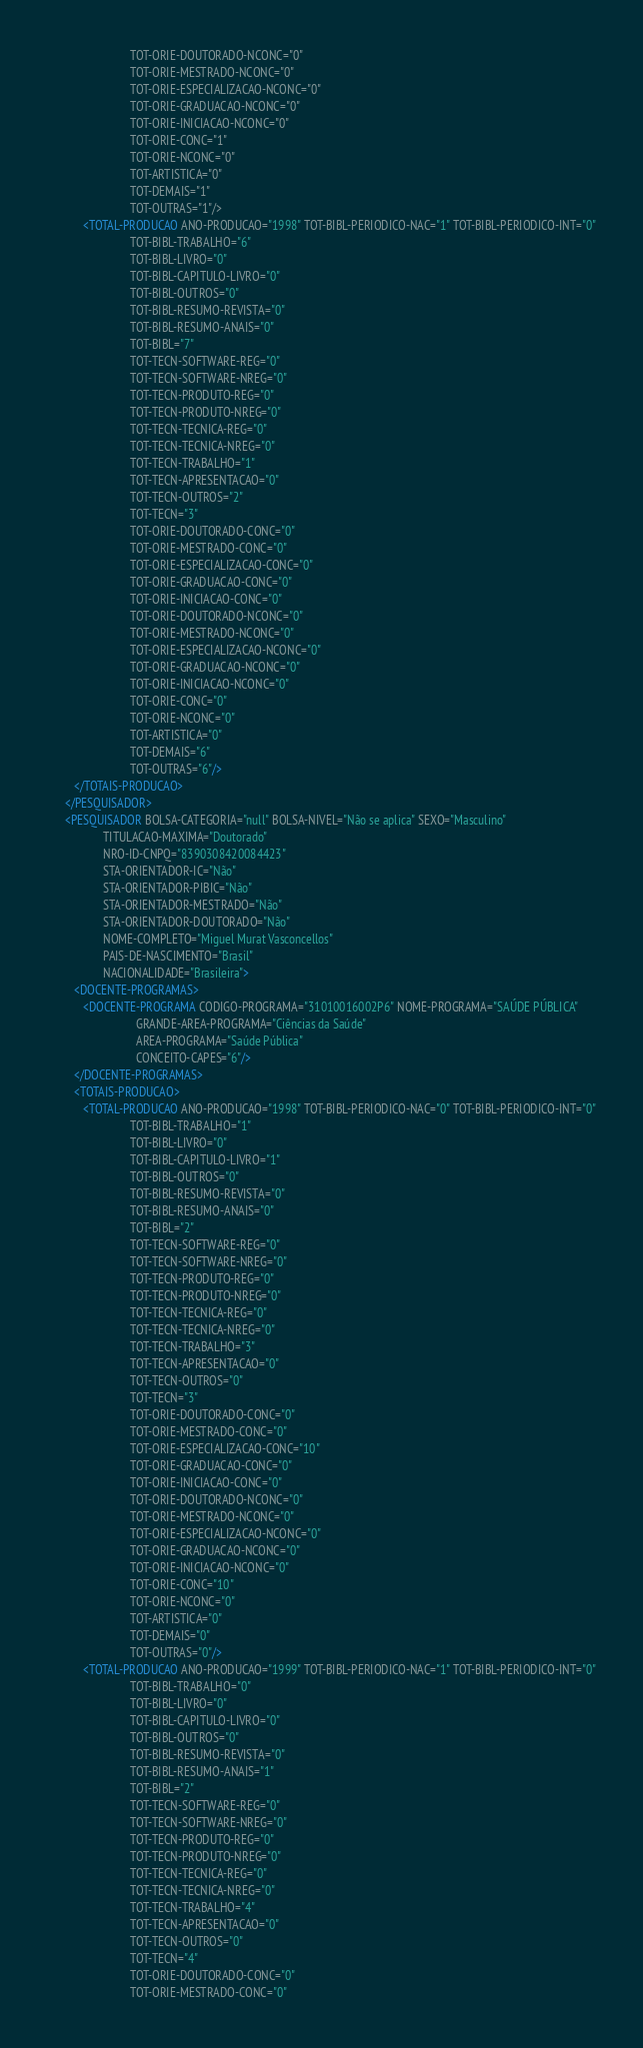<code> <loc_0><loc_0><loc_500><loc_500><_XML_>                            TOT-ORIE-DOUTORADO-NCONC="0"
                            TOT-ORIE-MESTRADO-NCONC="0"
                            TOT-ORIE-ESPECIALIZACAO-NCONC="0"
                            TOT-ORIE-GRADUACAO-NCONC="0"
                            TOT-ORIE-INICIACAO-NCONC="0"
                            TOT-ORIE-CONC="1"
                            TOT-ORIE-NCONC="0"
                            TOT-ARTISTICA="0"
                            TOT-DEMAIS="1"
                            TOT-OUTRAS="1"/>
            <TOTAL-PRODUCAO ANO-PRODUCAO="1998" TOT-BIBL-PERIODICO-NAC="1" TOT-BIBL-PERIODICO-INT="0"
                            TOT-BIBL-TRABALHO="6"
                            TOT-BIBL-LIVRO="0"
                            TOT-BIBL-CAPITULO-LIVRO="0"
                            TOT-BIBL-OUTROS="0"
                            TOT-BIBL-RESUMO-REVISTA="0"
                            TOT-BIBL-RESUMO-ANAIS="0"
                            TOT-BIBL="7"
                            TOT-TECN-SOFTWARE-REG="0"
                            TOT-TECN-SOFTWARE-NREG="0"
                            TOT-TECN-PRODUTO-REG="0"
                            TOT-TECN-PRODUTO-NREG="0"
                            TOT-TECN-TECNICA-REG="0"
                            TOT-TECN-TECNICA-NREG="0"
                            TOT-TECN-TRABALHO="1"
                            TOT-TECN-APRESENTACAO="0"
                            TOT-TECN-OUTROS="2"
                            TOT-TECN="3"
                            TOT-ORIE-DOUTORADO-CONC="0"
                            TOT-ORIE-MESTRADO-CONC="0"
                            TOT-ORIE-ESPECIALIZACAO-CONC="0"
                            TOT-ORIE-GRADUACAO-CONC="0"
                            TOT-ORIE-INICIACAO-CONC="0"
                            TOT-ORIE-DOUTORADO-NCONC="0"
                            TOT-ORIE-MESTRADO-NCONC="0"
                            TOT-ORIE-ESPECIALIZACAO-NCONC="0"
                            TOT-ORIE-GRADUACAO-NCONC="0"
                            TOT-ORIE-INICIACAO-NCONC="0"
                            TOT-ORIE-CONC="0"
                            TOT-ORIE-NCONC="0"
                            TOT-ARTISTICA="0"
                            TOT-DEMAIS="6"
                            TOT-OUTRAS="6"/>
         </TOTAIS-PRODUCAO>
      </PESQUISADOR>
      <PESQUISADOR BOLSA-CATEGORIA="null" BOLSA-NIVEL="Não se aplica" SEXO="Masculino"
                   TITULACAO-MAXIMA="Doutorado"
                   NRO-ID-CNPQ="8390308420084423"
                   STA-ORIENTADOR-IC="Não"
                   STA-ORIENTADOR-PIBIC="Não"
                   STA-ORIENTADOR-MESTRADO="Não"
                   STA-ORIENTADOR-DOUTORADO="Não"
                   NOME-COMPLETO="Miguel Murat Vasconcellos"
                   PAIS-DE-NASCIMENTO="Brasil"
                   NACIONALIDADE="Brasileira">
         <DOCENTE-PROGRAMAS>
            <DOCENTE-PROGRAMA CODIGO-PROGRAMA="31010016002P6" NOME-PROGRAMA="SAÚDE PÚBLICA"
                              GRANDE-AREA-PROGRAMA="Ciências da Saúde"
                              AREA-PROGRAMA="Saúde Pública"
                              CONCEITO-CAPES="6"/>
         </DOCENTE-PROGRAMAS>
         <TOTAIS-PRODUCAO>
            <TOTAL-PRODUCAO ANO-PRODUCAO="1998" TOT-BIBL-PERIODICO-NAC="0" TOT-BIBL-PERIODICO-INT="0"
                            TOT-BIBL-TRABALHO="1"
                            TOT-BIBL-LIVRO="0"
                            TOT-BIBL-CAPITULO-LIVRO="1"
                            TOT-BIBL-OUTROS="0"
                            TOT-BIBL-RESUMO-REVISTA="0"
                            TOT-BIBL-RESUMO-ANAIS="0"
                            TOT-BIBL="2"
                            TOT-TECN-SOFTWARE-REG="0"
                            TOT-TECN-SOFTWARE-NREG="0"
                            TOT-TECN-PRODUTO-REG="0"
                            TOT-TECN-PRODUTO-NREG="0"
                            TOT-TECN-TECNICA-REG="0"
                            TOT-TECN-TECNICA-NREG="0"
                            TOT-TECN-TRABALHO="3"
                            TOT-TECN-APRESENTACAO="0"
                            TOT-TECN-OUTROS="0"
                            TOT-TECN="3"
                            TOT-ORIE-DOUTORADO-CONC="0"
                            TOT-ORIE-MESTRADO-CONC="0"
                            TOT-ORIE-ESPECIALIZACAO-CONC="10"
                            TOT-ORIE-GRADUACAO-CONC="0"
                            TOT-ORIE-INICIACAO-CONC="0"
                            TOT-ORIE-DOUTORADO-NCONC="0"
                            TOT-ORIE-MESTRADO-NCONC="0"
                            TOT-ORIE-ESPECIALIZACAO-NCONC="0"
                            TOT-ORIE-GRADUACAO-NCONC="0"
                            TOT-ORIE-INICIACAO-NCONC="0"
                            TOT-ORIE-CONC="10"
                            TOT-ORIE-NCONC="0"
                            TOT-ARTISTICA="0"
                            TOT-DEMAIS="0"
                            TOT-OUTRAS="0"/>
            <TOTAL-PRODUCAO ANO-PRODUCAO="1999" TOT-BIBL-PERIODICO-NAC="1" TOT-BIBL-PERIODICO-INT="0"
                            TOT-BIBL-TRABALHO="0"
                            TOT-BIBL-LIVRO="0"
                            TOT-BIBL-CAPITULO-LIVRO="0"
                            TOT-BIBL-OUTROS="0"
                            TOT-BIBL-RESUMO-REVISTA="0"
                            TOT-BIBL-RESUMO-ANAIS="1"
                            TOT-BIBL="2"
                            TOT-TECN-SOFTWARE-REG="0"
                            TOT-TECN-SOFTWARE-NREG="0"
                            TOT-TECN-PRODUTO-REG="0"
                            TOT-TECN-PRODUTO-NREG="0"
                            TOT-TECN-TECNICA-REG="0"
                            TOT-TECN-TECNICA-NREG="0"
                            TOT-TECN-TRABALHO="4"
                            TOT-TECN-APRESENTACAO="0"
                            TOT-TECN-OUTROS="0"
                            TOT-TECN="4"
                            TOT-ORIE-DOUTORADO-CONC="0"
                            TOT-ORIE-MESTRADO-CONC="0"</code> 